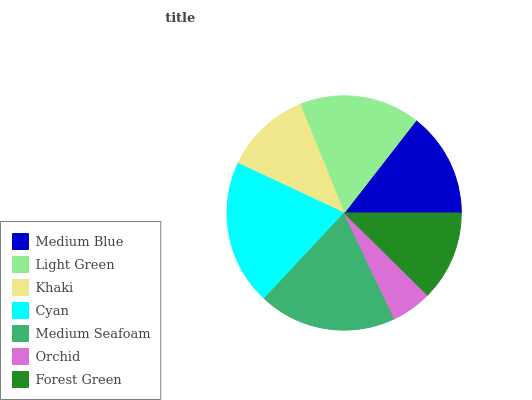Is Orchid the minimum?
Answer yes or no. Yes. Is Cyan the maximum?
Answer yes or no. Yes. Is Light Green the minimum?
Answer yes or no. No. Is Light Green the maximum?
Answer yes or no. No. Is Light Green greater than Medium Blue?
Answer yes or no. Yes. Is Medium Blue less than Light Green?
Answer yes or no. Yes. Is Medium Blue greater than Light Green?
Answer yes or no. No. Is Light Green less than Medium Blue?
Answer yes or no. No. Is Medium Blue the high median?
Answer yes or no. Yes. Is Medium Blue the low median?
Answer yes or no. Yes. Is Orchid the high median?
Answer yes or no. No. Is Khaki the low median?
Answer yes or no. No. 